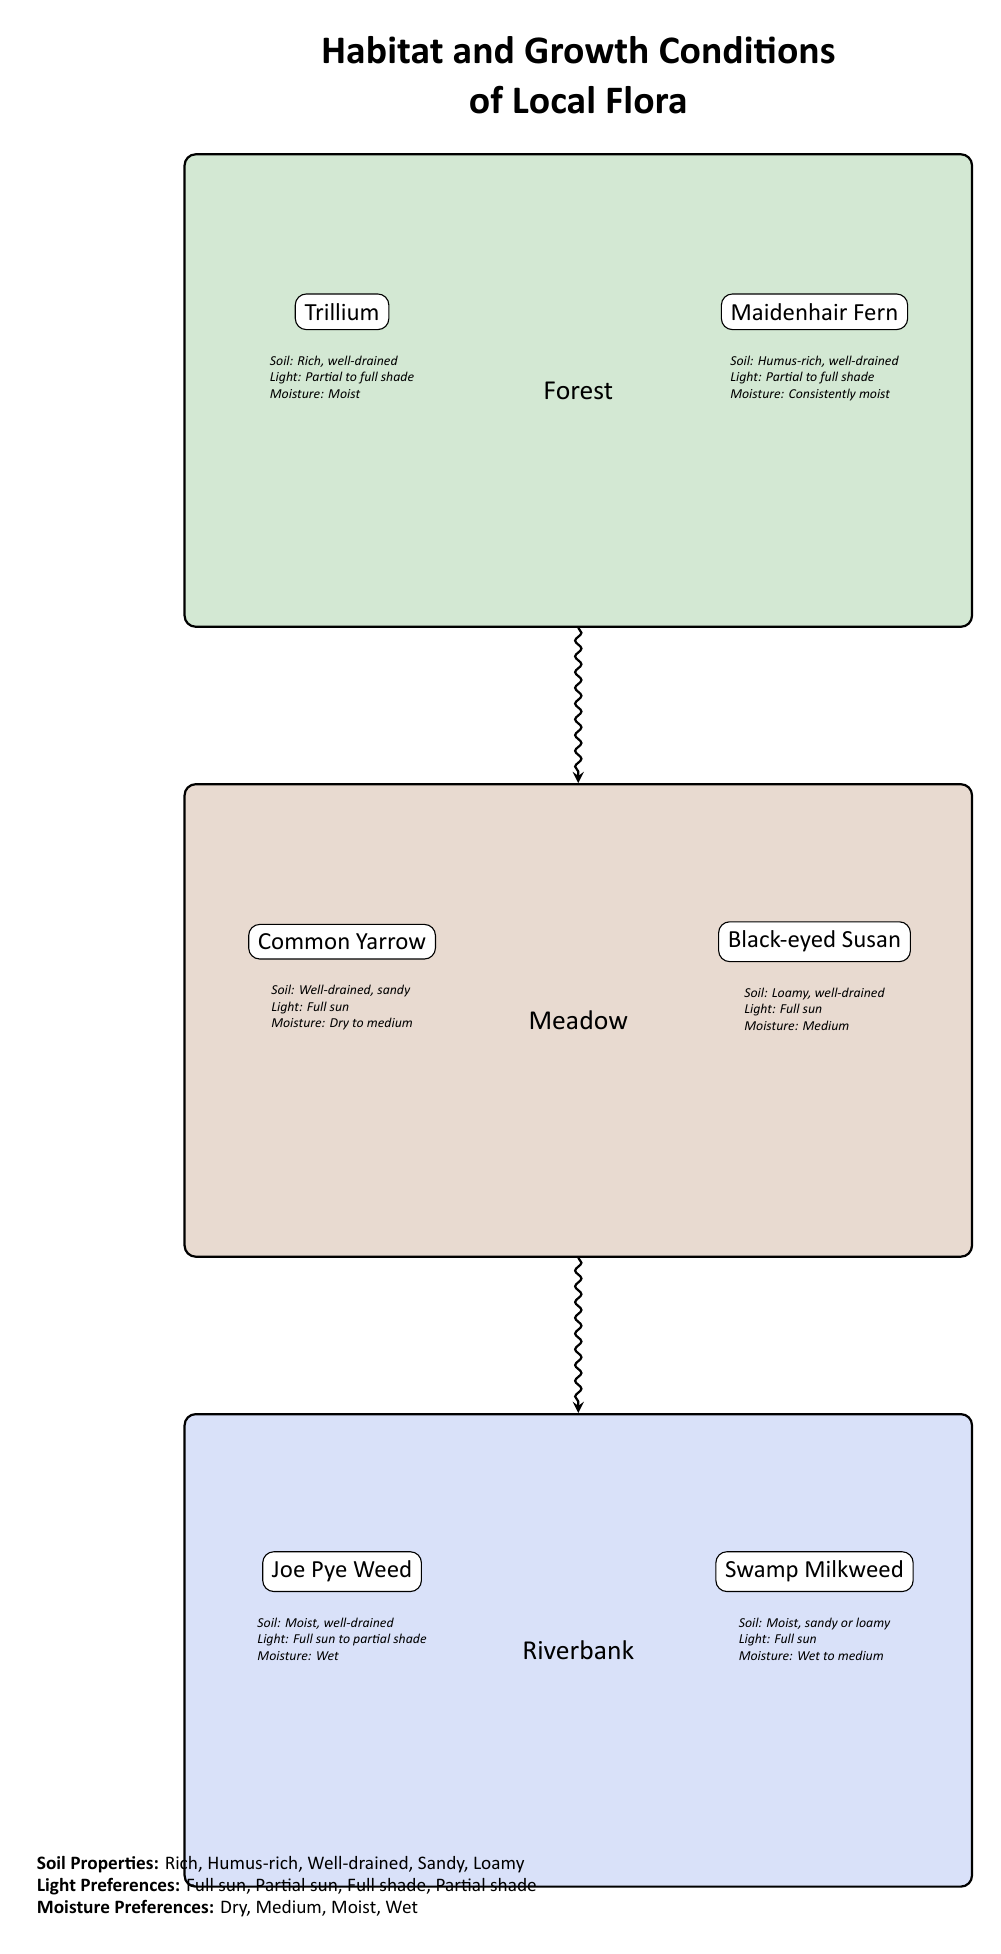What is the habitat at the top of the diagram? The diagram clearly labels the habitat at the top as "Forest".
Answer: Forest Which plant thrives in the meadow habitat? The diagram depicts two plants in the meadow, but the one named first is "Common Yarrow".
Answer: Common Yarrow How many different habitats are shown in the diagram? By counting the three habitats labeled (Forest, Meadow, Riverbank), we determine there are three distinct habitats illustrated.
Answer: 3 What is the moisture preference of Joe Pye Weed? The diagram lists the moisture preference of Joe Pye Weed as "Wet".
Answer: Wet What type of soil does the Black-eyed Susan prefer? The condition noted below Black-eyed Susan indicates it prefers "Loamy, well-drained" soil, which is the information provided in the diagram.
Answer: Loamy, well-drained If you move downward from the forest to the riverbank, what habitat do you pass through? The diagram indicates a directional flow from Forest to Meadow, followed by Meadow to Riverbank, making it clear that the Meadow habitat is between Forest and Riverbank.
Answer: Meadow What light condition is preferred by Maidenhair Fern? The diagram specifies that Maidenhair Fern prefers "Partial to full shade", which is a direct observation from the information provided.
Answer: Partial to full shade How does the moisture preference of Swamp Milkweed compare to that of Joe Pye Weed? By comparing the two depicted plants, we see that Swamp Milkweed prefers "Wet to medium" moisture, while Joe Pye Weed prefers "Wet", indicating Swamp Milkweed has a wider moisture range.
Answer: Swamp Milkweed prefers Wet to medium What is the directional flow between the habitats? The arrows in the diagram indicate a downward flow, starting from Forest, then to Meadow, and finally to Riverbank, showing the sequence from one habitat to the next.
Answer: Forest to Meadow to Riverbank 